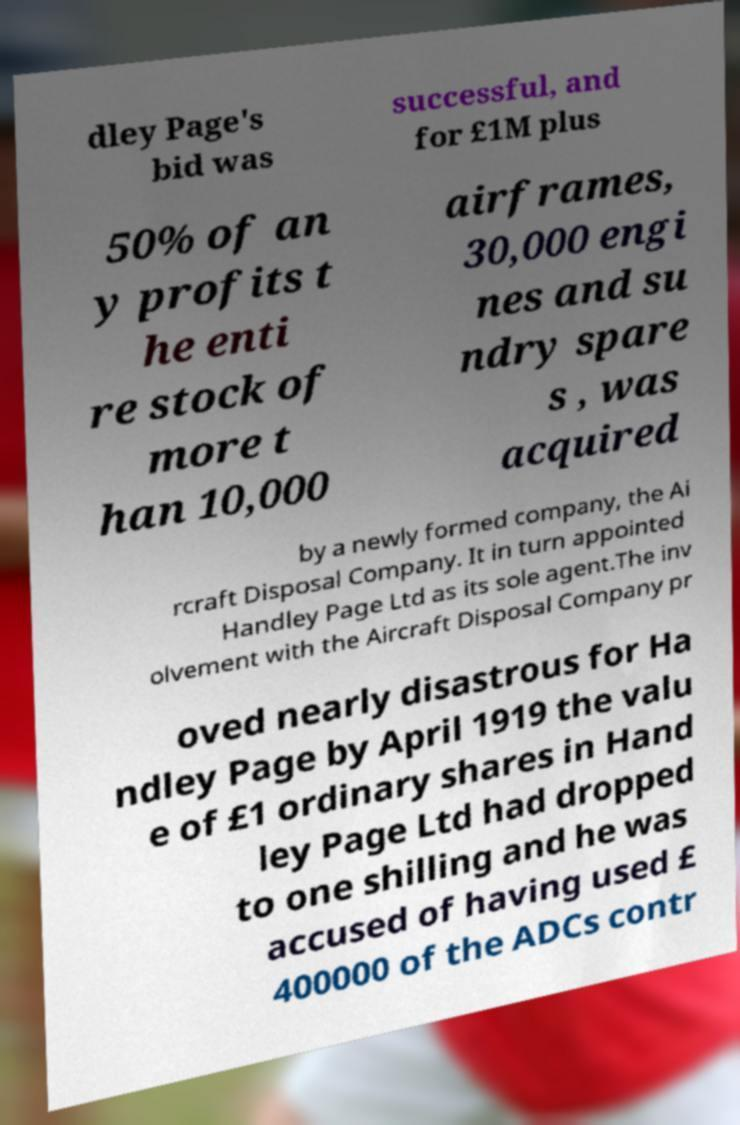Could you assist in decoding the text presented in this image and type it out clearly? dley Page's bid was successful, and for £1M plus 50% of an y profits t he enti re stock of more t han 10,000 airframes, 30,000 engi nes and su ndry spare s , was acquired by a newly formed company, the Ai rcraft Disposal Company. It in turn appointed Handley Page Ltd as its sole agent.The inv olvement with the Aircraft Disposal Company pr oved nearly disastrous for Ha ndley Page by April 1919 the valu e of £1 ordinary shares in Hand ley Page Ltd had dropped to one shilling and he was accused of having used £ 400000 of the ADCs contr 